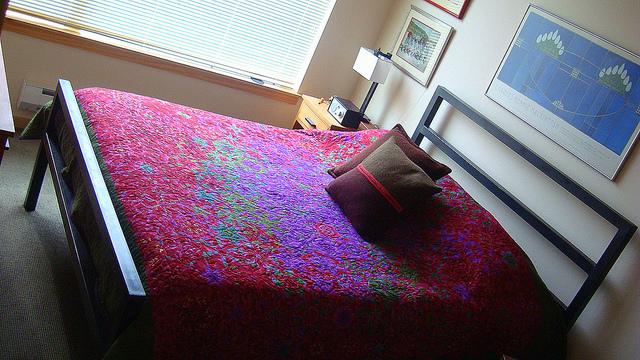Is the bed colorful?
Write a very short answer. Yes. How many pillows are on the bed?
Concise answer only. 2. Where is the alarm clock?
Keep it brief. On nightstand. 